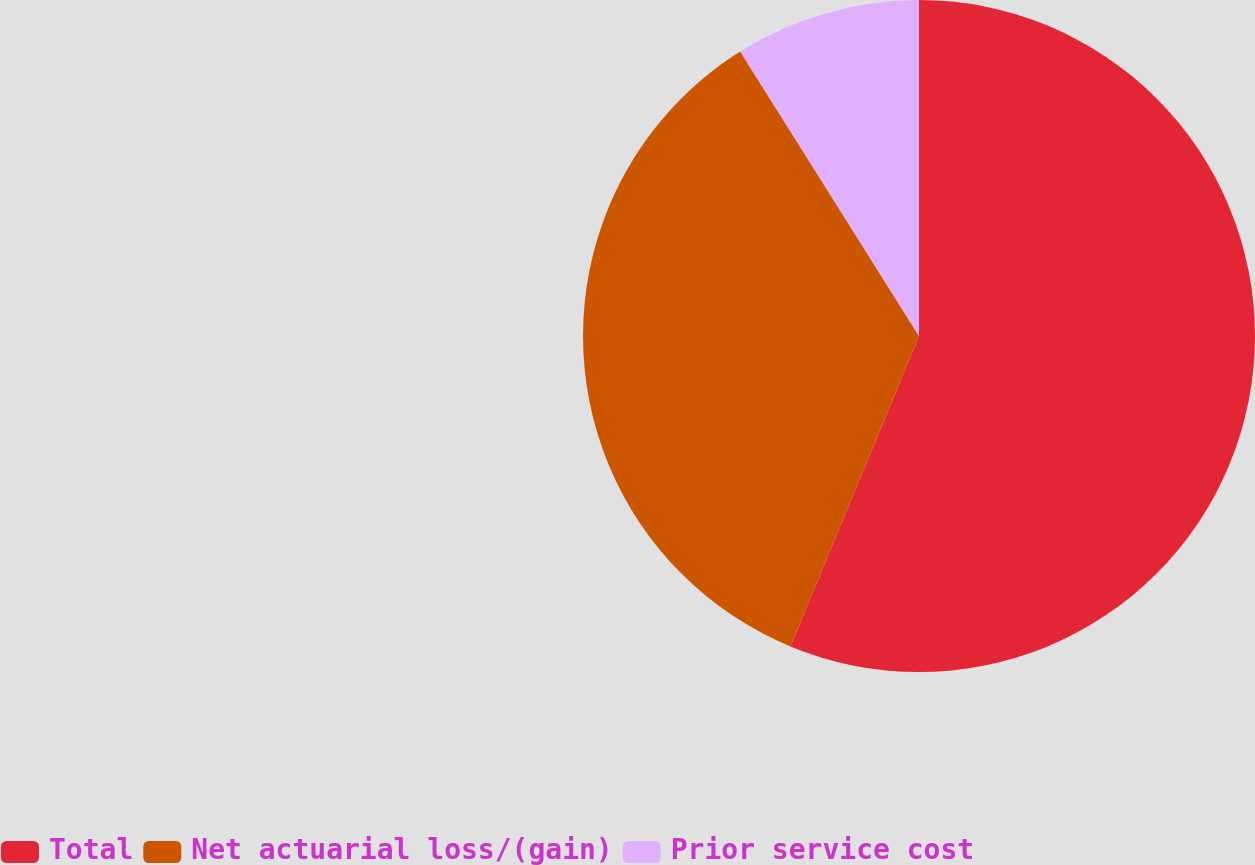Convert chart. <chart><loc_0><loc_0><loc_500><loc_500><pie_chart><fcel>Total<fcel>Net actuarial loss/(gain)<fcel>Prior service cost<nl><fcel>56.25%<fcel>34.82%<fcel>8.93%<nl></chart> 